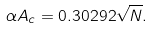Convert formula to latex. <formula><loc_0><loc_0><loc_500><loc_500>\alpha A _ { c } = 0 . 3 0 2 9 2 \sqrt { N } .</formula> 